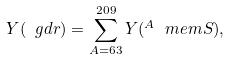<formula> <loc_0><loc_0><loc_500><loc_500>Y ( \ g d r ) = \sum _ { A = 6 3 } ^ { 2 0 9 } Y ( ^ { A } \ m e m { S } ) ,</formula> 